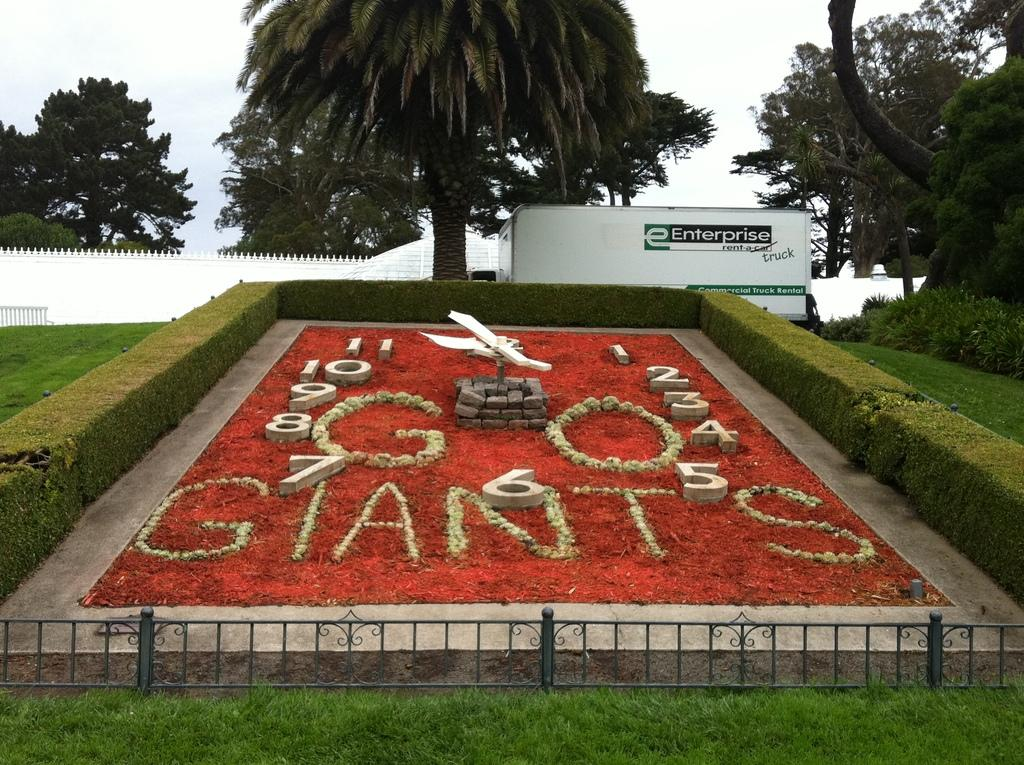What type of natural environment is depicted in the image? The image contains water, grass, and trees, which are elements of a natural environment. What type of surface can be seen in the image? There is a board in the image, which is a flat surface. What is visible in the sky in the image? The sky is visible in the image, but no specific details about the sky are mentioned in the facts. How many types of vegetation are present in the image? There are two types of vegetation present in the image: grass and trees. What type of love can be seen expressed between the trees in the image? There is no indication of love or any emotional expression between the trees in the image. --- Facts: 1. There is a person in the image. 2. The person is wearing a hat. 3. The person is holding a book. 4. There is a table in the image. 5. The table has a lamp on it. Absurd Topics: dance, ocean, laughter Conversation: What is the main subject of the image? The main subject of the image is a person. What is the person wearing in the image? The person is wearing a hat in the image. What is the person holding in the image? The person is holding a book in the image. What type of furniture is present in the image? There is a table in the image. What object is on the table in the image? The table has a lamp on it. Reasoning: Let's think step by step in order to produce the conversation. We start by identifying the main subject of the image, which is the person. Then, we describe the person's attire and what they are holding, which is a hat and a book, respectively. Next, we mention the presence of a table, which is a piece of furniture. Finally, we identify the object on the table, which is a lamp. Absurd Question/Answer: What type of dance is the person performing in the image? There is no indication of dancing or any movement in the image; the person is simply holding a book. 